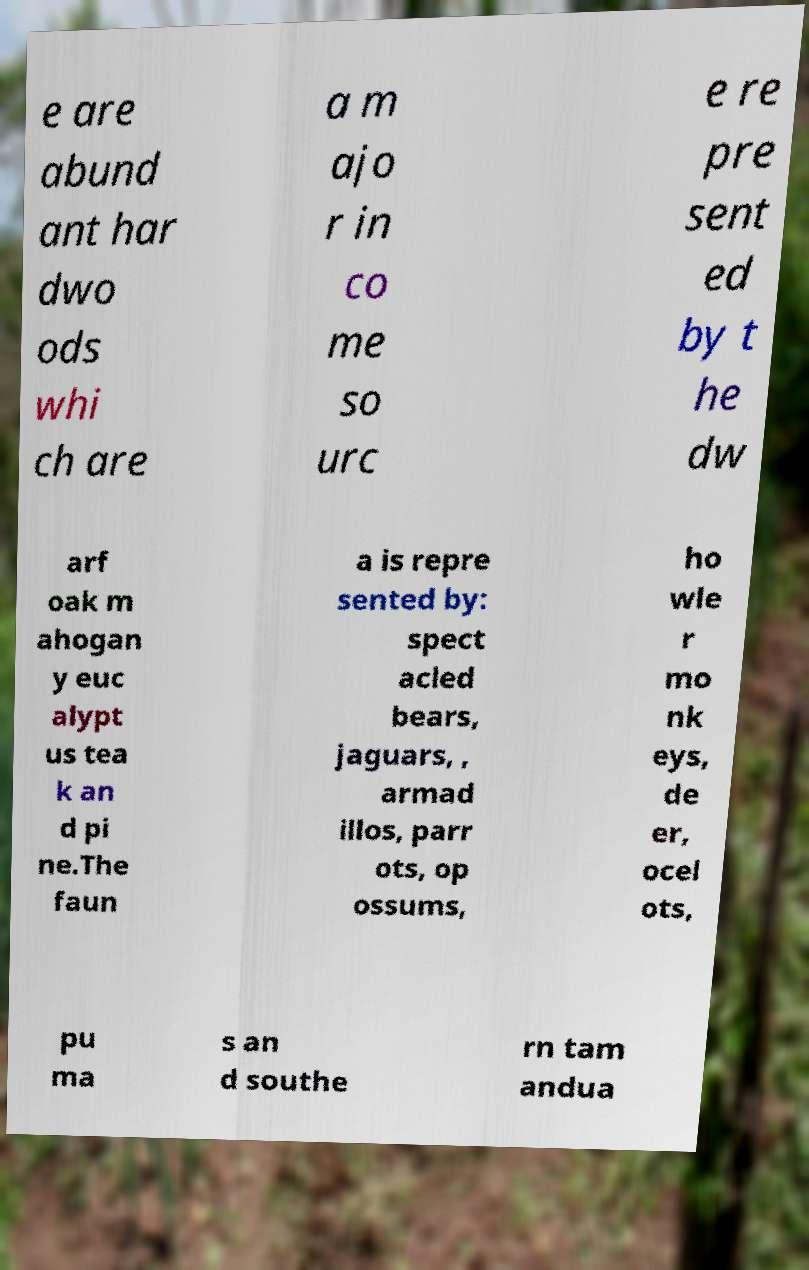Can you read and provide the text displayed in the image?This photo seems to have some interesting text. Can you extract and type it out for me? e are abund ant har dwo ods whi ch are a m ajo r in co me so urc e re pre sent ed by t he dw arf oak m ahogan y euc alypt us tea k an d pi ne.The faun a is repre sented by: spect acled bears, jaguars, , armad illos, parr ots, op ossums, ho wle r mo nk eys, de er, ocel ots, pu ma s an d southe rn tam andua 